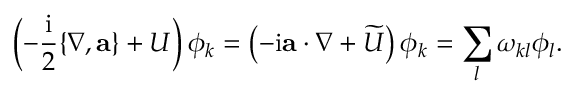<formula> <loc_0><loc_0><loc_500><loc_500>\left ( - \frac { i } { 2 } \{ \nabla , a \} + U \right ) \phi _ { k } = \left ( - i a \cdot \nabla + \widetilde { U } \right ) \phi _ { k } = \sum _ { l } \omega _ { k l } \phi _ { l } .</formula> 